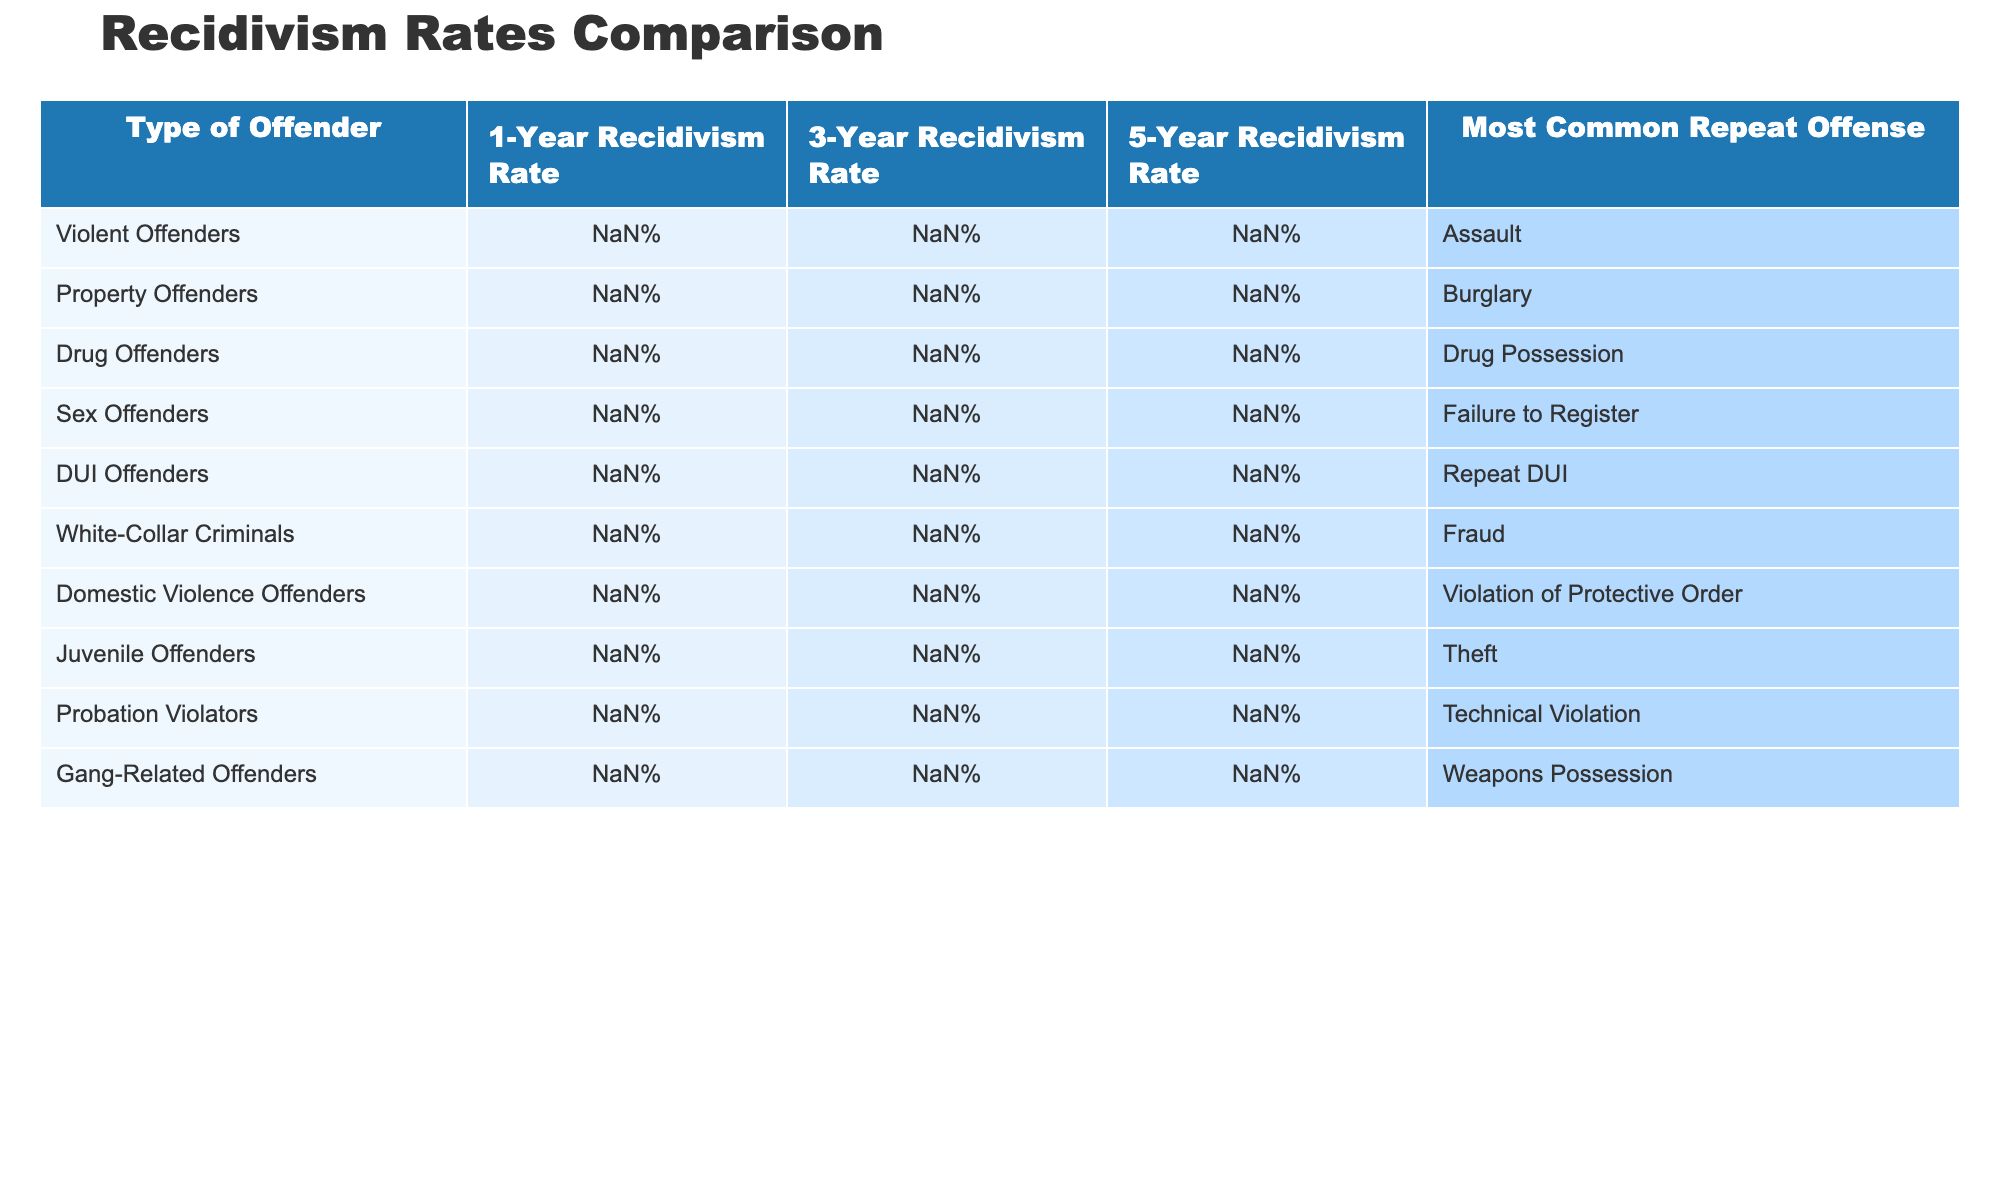What is the recidivism rate for Drug Offenders after 3 years? The table shows that the 3-Year Recidivism Rate for Drug Offenders is listed as 60%.
Answer: 60% Which type of offender has the highest 5-year recidivism rate? Looking through the 5-Year Recidivism Rate column, Juvenile Offenders have the highest rate at 78%.
Answer: Juvenile Offenders What is the difference between the 1-Year Recidivism Rate of Property Offenders and White-Collar Criminals? The 1-Year Recidivism Rate for Property Offenders is 31% and for White-Collar Criminals is 11%. The difference is 31% - 11% = 20%.
Answer: 20% Do more violent offenders tend to recidivate within 5 years compared to sex offenders? The 5-Year Recidivism Rate for Violent Offenders is 62% while for Sex Offenders it is 39%. Since 62% is greater than 39%, the statement is true.
Answer: Yes What is the average 3-Year Recidivism Rate for all types of offenders in the table? To find the average, we add the 3-Year Recidivism Rates: 45% + 53% + 60% + 27% + 41% + 20% + 57% + 65% + 69% + 59% =  456%. There are 10 offender types, so we divide by 10, resulting in an average of 45.6%.
Answer: 45.6% What is the most common repeat offense among Domestic Violence Offenders? The table specifies that the most common repeat offense for Domestic Violence Offenders is "Violation of Protective Order."
Answer: Violation of Protective Order How does the 1-Year Recidivism Rate for Probation Violators compare to that of Sex Offenders? The 1-Year Recidivism Rate for Probation Violators is 43% and for Sex Offenders is 13%. Comparing the two shows that 43% is significantly higher than 13%.
Answer: 43% is higher than 13% What percentage of Juvenile Offenders recidivate within 5 years? The table indicates that 78% of Juvenile Offenders have a 5-Year Recidivism Rate.
Answer: 78% 